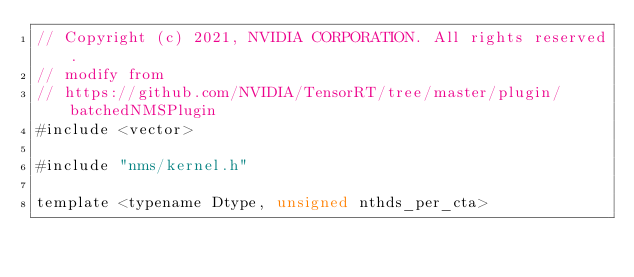Convert code to text. <code><loc_0><loc_0><loc_500><loc_500><_Cuda_>// Copyright (c) 2021, NVIDIA CORPORATION. All rights reserved.
// modify from
// https://github.com/NVIDIA/TensorRT/tree/master/plugin/batchedNMSPlugin
#include <vector>

#include "nms/kernel.h"

template <typename Dtype, unsigned nthds_per_cta></code> 